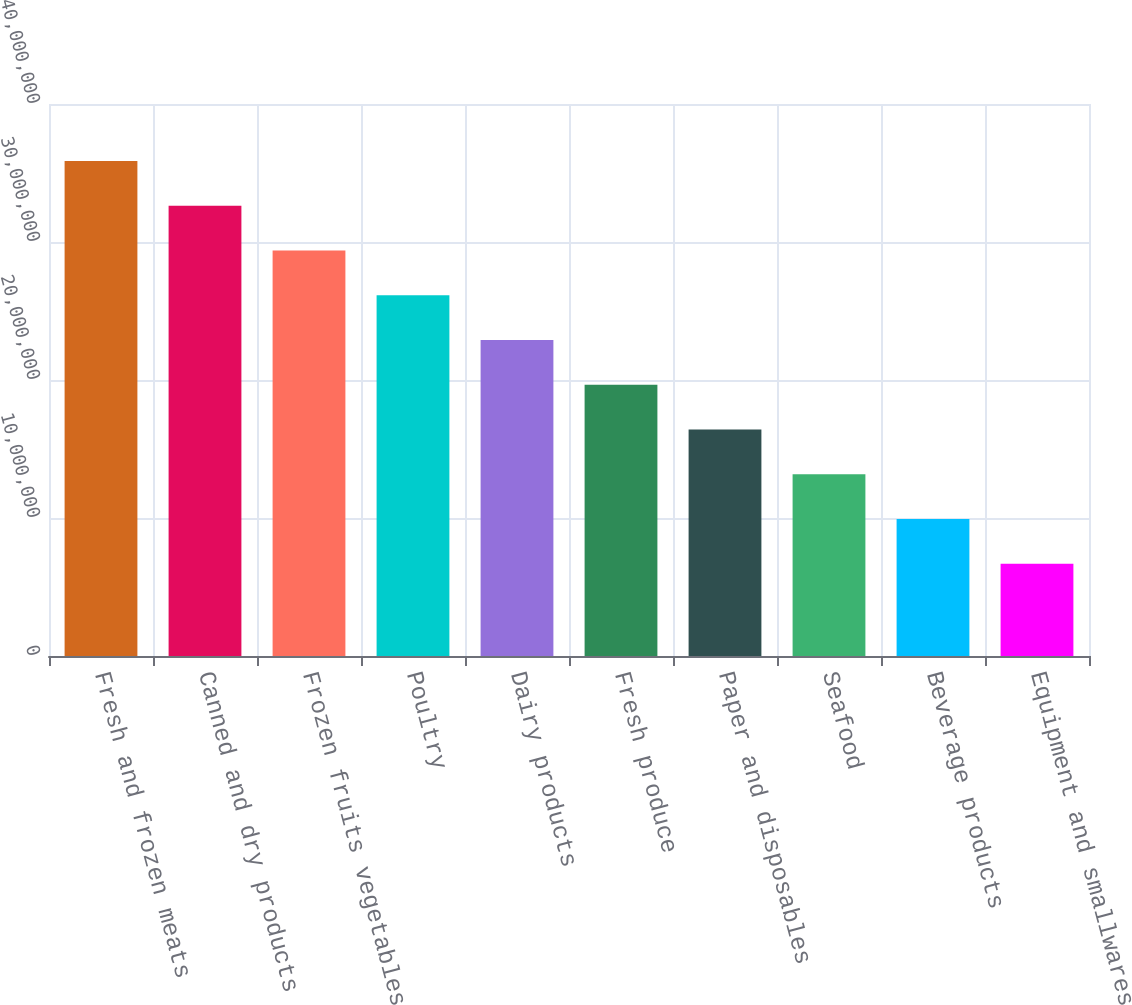<chart> <loc_0><loc_0><loc_500><loc_500><bar_chart><fcel>Fresh and frozen meats<fcel>Canned and dry products<fcel>Frozen fruits vegetables<fcel>Poultry<fcel>Dairy products<fcel>Fresh produce<fcel>Paper and disposables<fcel>Seafood<fcel>Beverage products<fcel>Equipment and smallwares<nl><fcel>3.58707e+07<fcel>3.26284e+07<fcel>2.93861e+07<fcel>2.61438e+07<fcel>2.29015e+07<fcel>1.96592e+07<fcel>1.64169e+07<fcel>1.31746e+07<fcel>9.93226e+06<fcel>6.68995e+06<nl></chart> 